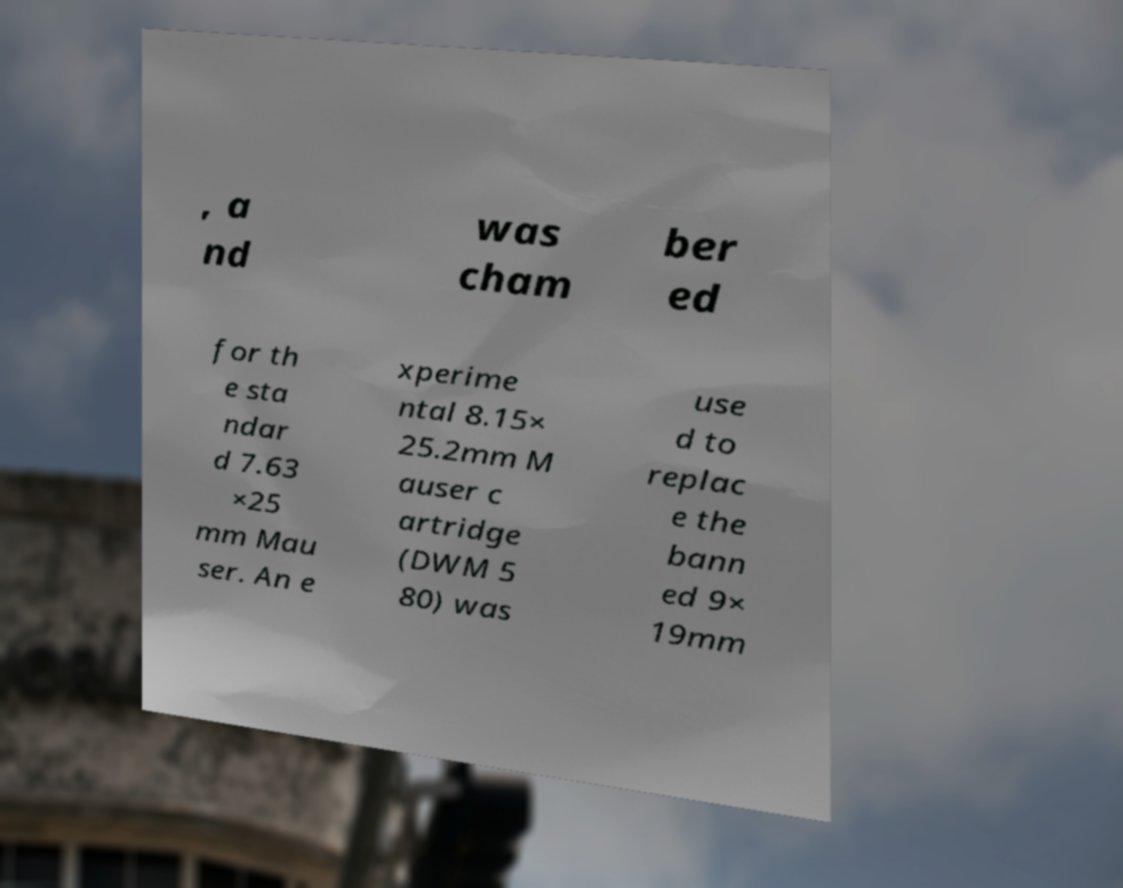There's text embedded in this image that I need extracted. Can you transcribe it verbatim? , a nd was cham ber ed for th e sta ndar d 7.63 ×25 mm Mau ser. An e xperime ntal 8.15× 25.2mm M auser c artridge (DWM 5 80) was use d to replac e the bann ed 9× 19mm 